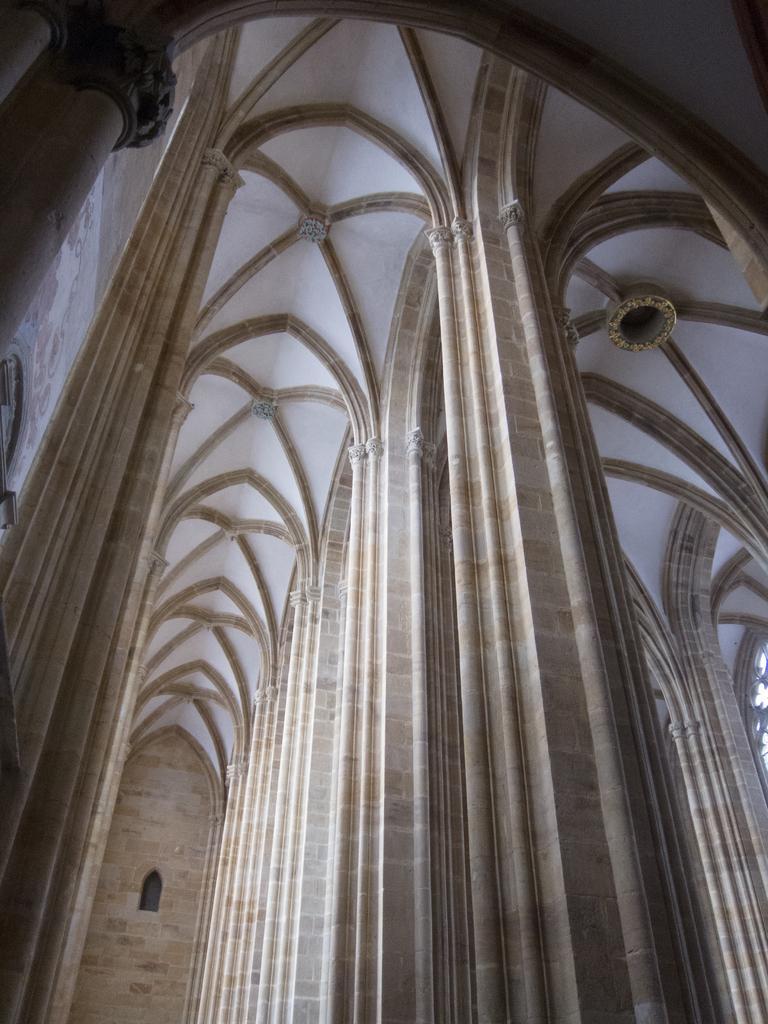Could you give a brief overview of what you see in this image? In this picture we can see a window, pillars, ceiling and this is an inside view of a building. 